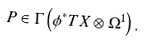Convert formula to latex. <formula><loc_0><loc_0><loc_500><loc_500>P \in \Gamma \left ( \phi ^ { * } T X \otimes \Omega ^ { 1 } \right ) . \\</formula> 